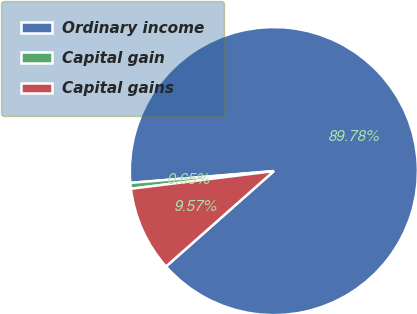Convert chart to OTSL. <chart><loc_0><loc_0><loc_500><loc_500><pie_chart><fcel>Ordinary income<fcel>Capital gain<fcel>Capital gains<nl><fcel>89.78%<fcel>0.65%<fcel>9.57%<nl></chart> 